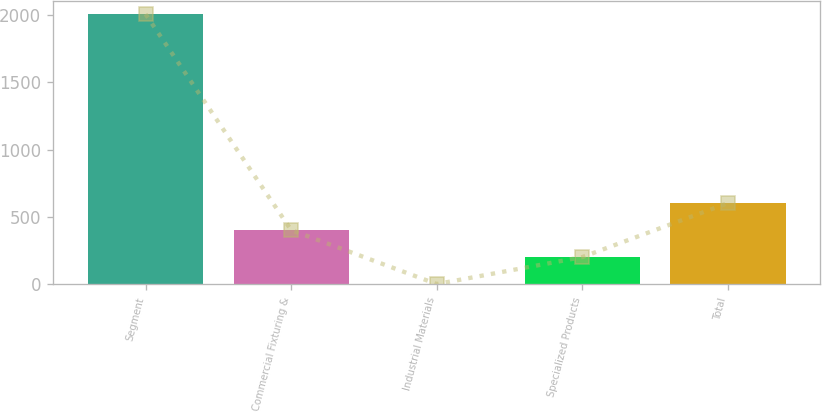<chart> <loc_0><loc_0><loc_500><loc_500><bar_chart><fcel>Segment<fcel>Commercial Fixturing &<fcel>Industrial Materials<fcel>Specialized Products<fcel>Total<nl><fcel>2007<fcel>403.8<fcel>3<fcel>203.4<fcel>604.2<nl></chart> 